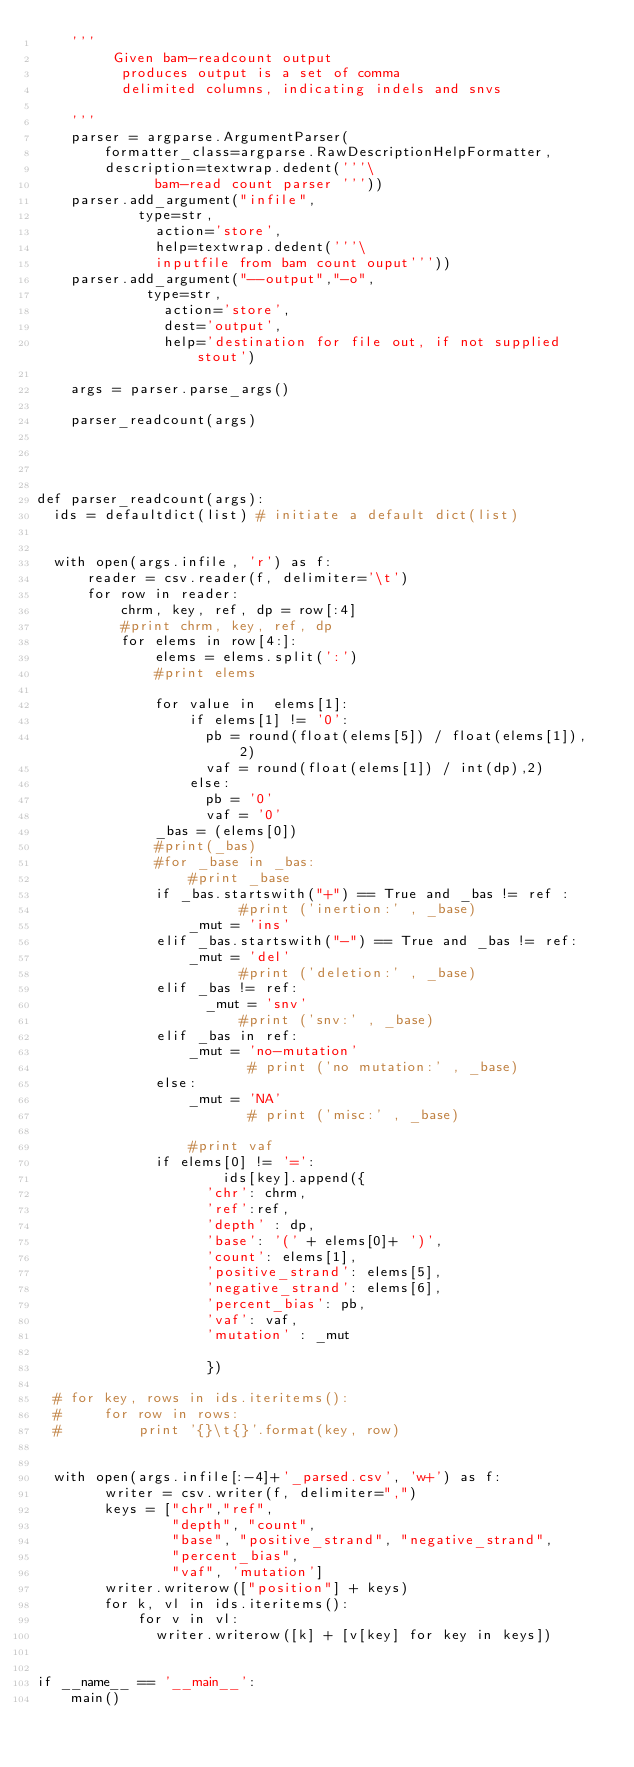<code> <loc_0><loc_0><loc_500><loc_500><_Python_>    '''
         Given bam-readcount output
          produces output is a set of comma
          delimited columns, indicating indels and snvs

    '''
    parser = argparse.ArgumentParser(
		    formatter_class=argparse.RawDescriptionHelpFormatter,
 		    description=textwrap.dedent('''\
              bam-read count parser '''))
    parser.add_argument("infile",
    	      type=str,
              action='store',
              help=textwrap.dedent('''\
              inputfile from bam count ouput'''))
    parser.add_argument("--output","-o",
    	       type=str,
               action='store',
               dest='output',
               help='destination for file out, if not supplied stout')

    args = parser.parse_args()

    parser_readcount(args)




def parser_readcount(args):
  ids = defaultdict(list) # initiate a default dict(list)


  with open(args.infile, 'r') as f:
      reader = csv.reader(f, delimiter='\t')
      for row in reader:
          chrm, key, ref, dp = row[:4]
          #print chrm, key, ref, dp
          for elems in row[4:]:
              elems = elems.split(':')
              #print elems
              
              for value in  elems[1]:
                  if elems[1] != '0':
                    pb = round(float(elems[5]) / float(elems[1]), 2)
                    vaf = round(float(elems[1]) / int(dp),2)
                  else:
                    pb = '0'
                    vaf = '0'
              _bas = (elems[0])
              #print(_bas)
              #for _base in _bas:
                  #print _base
              if _bas.startswith("+") == True and _bas != ref :
                        #print ('inertion:' , _base)
                  _mut = 'ins' 
              elif _bas.startswith("-") == True and _bas != ref:
                  _mut = 'del'
                        #print ('deletion:' , _base)
              elif _bas != ref:
                    _mut = 'snv'
                        #print ('snv:' , _base)
              elif _bas in ref:
                  _mut = 'no-mutation'
                         # print ('no mutation:' , _base)
              else:
                  _mut = 'NA'    
                         # print ('misc:' , _base)

                  #print vaf
              if elems[0] != '=':
                      ids[key].append({
                    'chr': chrm,
                    'ref':ref,
                    'depth' : dp,
                    'base': '(' + elems[0]+ ')',
                    'count': elems[1],
                    'positive_strand': elems[5],
                    'negative_strand': elems[6],
                    'percent_bias': pb,
                    'vaf': vaf,
                    'mutation' : _mut

                    })

  # for key, rows in ids.iteritems():
  #     for row in rows:
  #         print '{}\t{}'.format(key, row)


  with open(args.infile[:-4]+'_parsed.csv', 'w+') as f:
        writer = csv.writer(f, delimiter=",")
        keys = ["chr","ref",
                "depth", "count", 
                "base", "positive_strand", "negative_strand", 
                "percent_bias", 
                "vaf", 'mutation']
        writer.writerow(["position"] + keys)
        for k, vl in ids.iteritems():
            for v in vl:
              writer.writerow([k] + [v[key] for key in keys])


if __name__ == '__main__':
    main()
</code> 